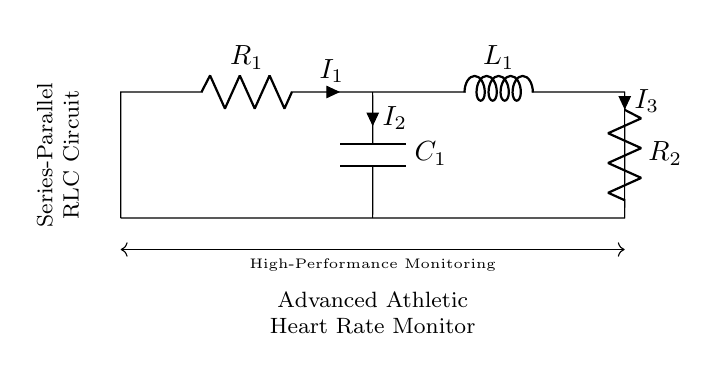What are the components in this circuit? The circuit includes a resistor (R1), a capacitor (C1), another resistor (R2), and an inductor (L1). Each component serves a specific role in managing the heart rate signals.
Answer: Resistor, Capacitor, Inductor What is the total current entering the circuit? The total current entering the circuit is given by I1, which flows through the entire series portion of the circuit before reaching the parallel components.
Answer: I1 Which component has the highest impedance in this circuit? The inductor typically has the highest impedance at alternating current frequency in an RLC circuit, affecting how the circuit responds to changes in the heart rate signal.
Answer: L1 What is the configuration of C1? C1 is connected in parallel with the series combination of R1 and L1, allowing it to control the voltage across it and filter the heart rate signal effectively.
Answer: Parallel How do R2 and C1 influence the circuit performance? R2 and C1 together form a parallel part of the circuit that can help to dampen oscillations and improve stability in the monitoring system by affecting the total impedance.
Answer: Stabilizes oscillations What can be inferred about the role of R1 in the circuit? R1 limits the current flowing through the circuit, helping to prevent damage to sensitive components such as C1, and controlling energy flow.
Answer: Current limiter 